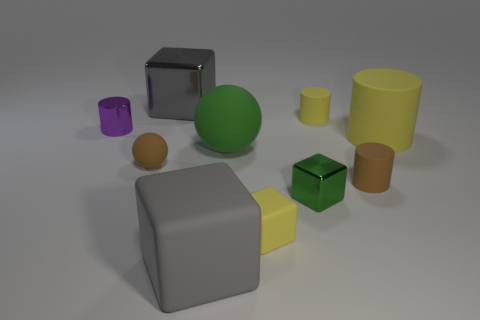There is a small cylinder that is the same color as the large cylinder; what is its material?
Keep it short and to the point. Rubber. There is a sphere that is in front of the green thing that is left of the small green cube that is in front of the small ball; what is its material?
Ensure brevity in your answer.  Rubber. Are there an equal number of big cylinders in front of the green matte sphere and small things?
Your answer should be compact. No. Is there any other thing that has the same size as the green rubber object?
Your answer should be very brief. Yes. How many objects are big green balls or large gray rubber objects?
Your answer should be very brief. 2. What is the shape of the green thing that is made of the same material as the large yellow cylinder?
Your answer should be very brief. Sphere. What size is the matte ball on the left side of the big gray thing in front of the small purple shiny cylinder?
Make the answer very short. Small. What number of large things are either gray shiny spheres or metallic cylinders?
Offer a very short reply. 0. What number of other objects are the same color as the small rubber ball?
Keep it short and to the point. 1. Do the matte object that is left of the gray rubber thing and the gray cube in front of the tiny brown ball have the same size?
Your response must be concise. No. 